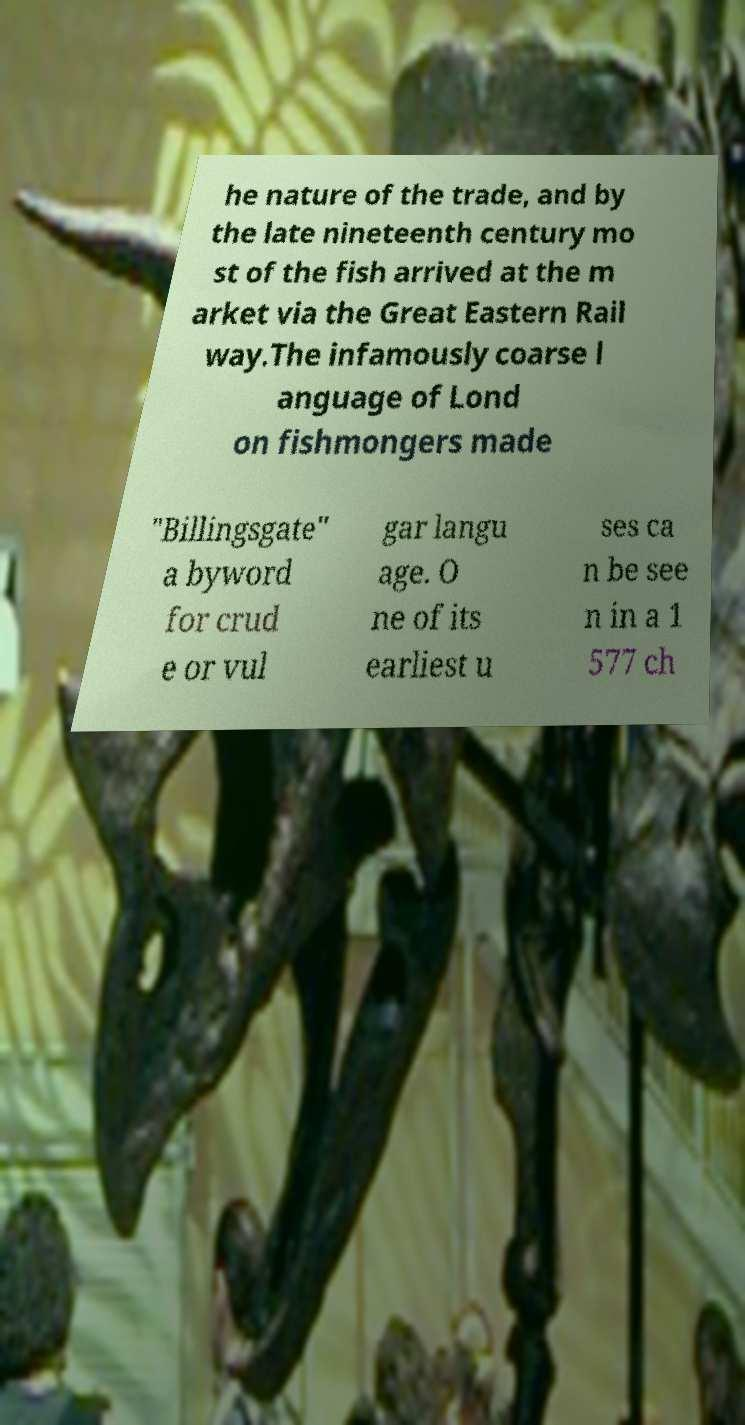Can you accurately transcribe the text from the provided image for me? he nature of the trade, and by the late nineteenth century mo st of the fish arrived at the m arket via the Great Eastern Rail way.The infamously coarse l anguage of Lond on fishmongers made "Billingsgate" a byword for crud e or vul gar langu age. O ne of its earliest u ses ca n be see n in a 1 577 ch 